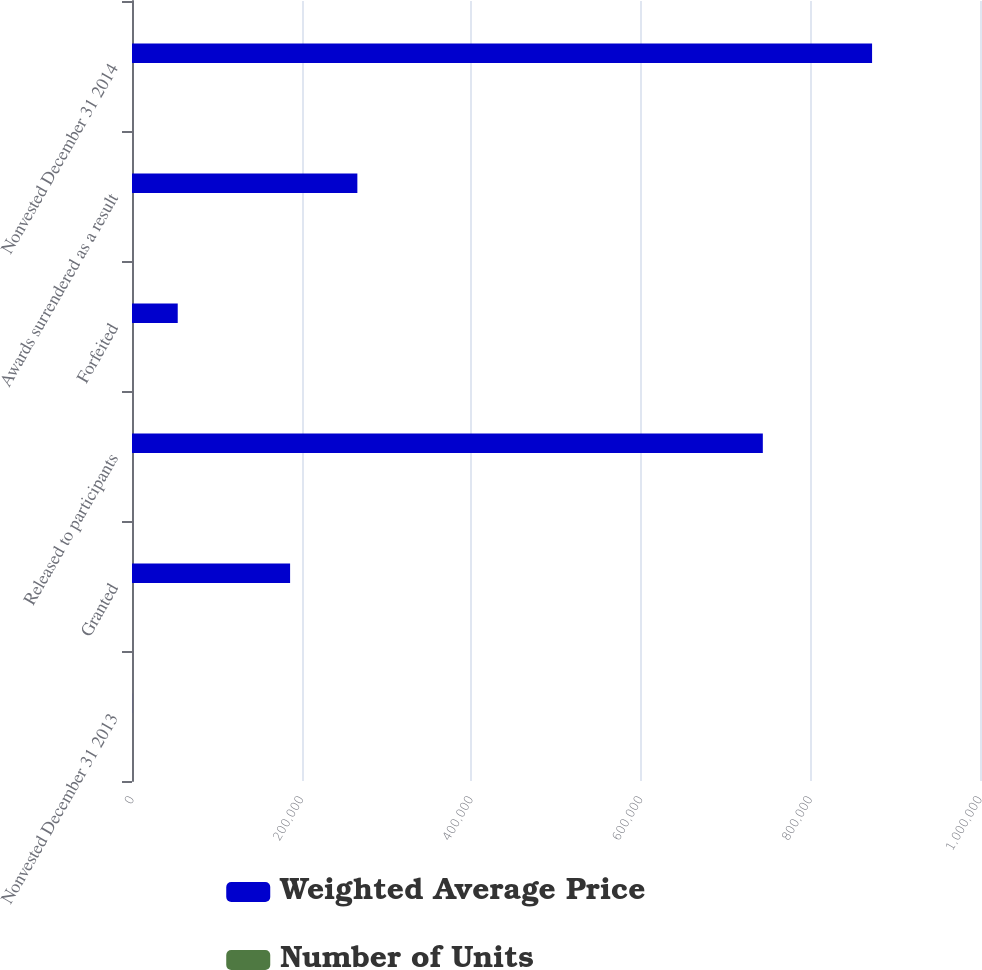<chart> <loc_0><loc_0><loc_500><loc_500><stacked_bar_chart><ecel><fcel>Nonvested December 31 2013<fcel>Granted<fcel>Released to participants<fcel>Forfeited<fcel>Awards surrendered as a result<fcel>Nonvested December 31 2014<nl><fcel>Weighted Average Price<fcel>64.75<fcel>186436<fcel>743897<fcel>53927<fcel>265750<fcel>872730<nl><fcel>Number of Units<fcel>41.1<fcel>64.75<fcel>34.68<fcel>48.99<fcel>47.62<fcel>44.55<nl></chart> 